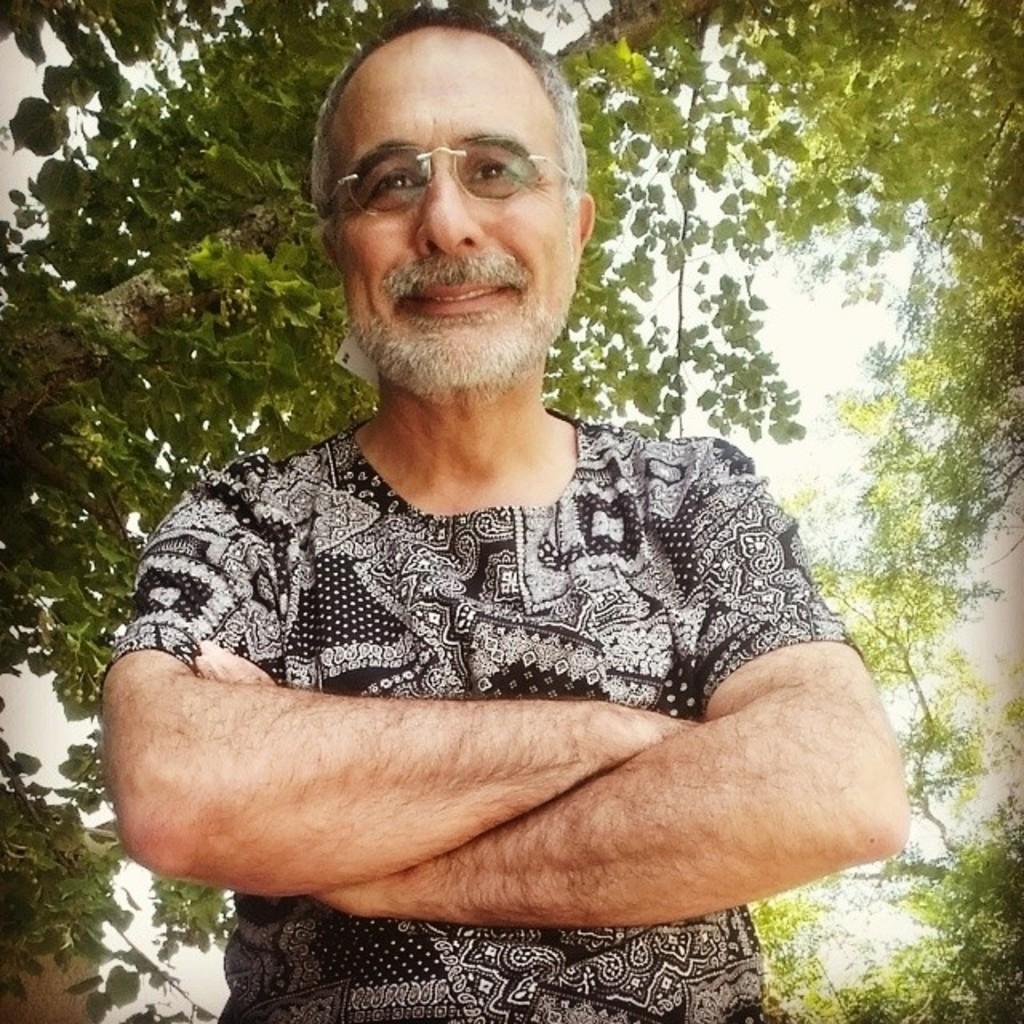How would you summarize this image in a sentence or two? In this picture I can see there is a man standing here and he is wearing a black shirt and it has some white designs and in the backdrop I can see there are trees. 